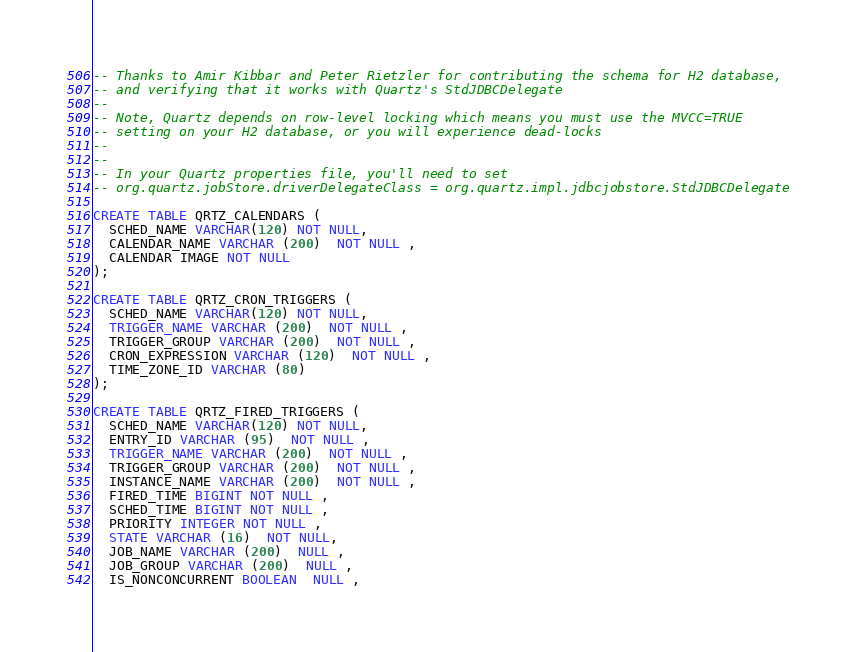Convert code to text. <code><loc_0><loc_0><loc_500><loc_500><_SQL_>-- Thanks to Amir Kibbar and Peter Rietzler for contributing the schema for H2 database, 
-- and verifying that it works with Quartz's StdJDBCDelegate
--
-- Note, Quartz depends on row-level locking which means you must use the MVCC=TRUE 
-- setting on your H2 database, or you will experience dead-locks
--
--
-- In your Quartz properties file, you'll need to set 
-- org.quartz.jobStore.driverDelegateClass = org.quartz.impl.jdbcjobstore.StdJDBCDelegate

CREATE TABLE QRTZ_CALENDARS (
  SCHED_NAME VARCHAR(120) NOT NULL,
  CALENDAR_NAME VARCHAR (200)  NOT NULL ,
  CALENDAR IMAGE NOT NULL
);

CREATE TABLE QRTZ_CRON_TRIGGERS (
  SCHED_NAME VARCHAR(120) NOT NULL,
  TRIGGER_NAME VARCHAR (200)  NOT NULL ,
  TRIGGER_GROUP VARCHAR (200)  NOT NULL ,
  CRON_EXPRESSION VARCHAR (120)  NOT NULL ,
  TIME_ZONE_ID VARCHAR (80) 
);

CREATE TABLE QRTZ_FIRED_TRIGGERS (
  SCHED_NAME VARCHAR(120) NOT NULL,
  ENTRY_ID VARCHAR (95)  NOT NULL ,
  TRIGGER_NAME VARCHAR (200)  NOT NULL ,
  TRIGGER_GROUP VARCHAR (200)  NOT NULL ,
  INSTANCE_NAME VARCHAR (200)  NOT NULL ,
  FIRED_TIME BIGINT NOT NULL ,
  SCHED_TIME BIGINT NOT NULL ,
  PRIORITY INTEGER NOT NULL ,
  STATE VARCHAR (16)  NOT NULL,
  JOB_NAME VARCHAR (200)  NULL ,
  JOB_GROUP VARCHAR (200)  NULL ,
  IS_NONCONCURRENT BOOLEAN  NULL ,</code> 